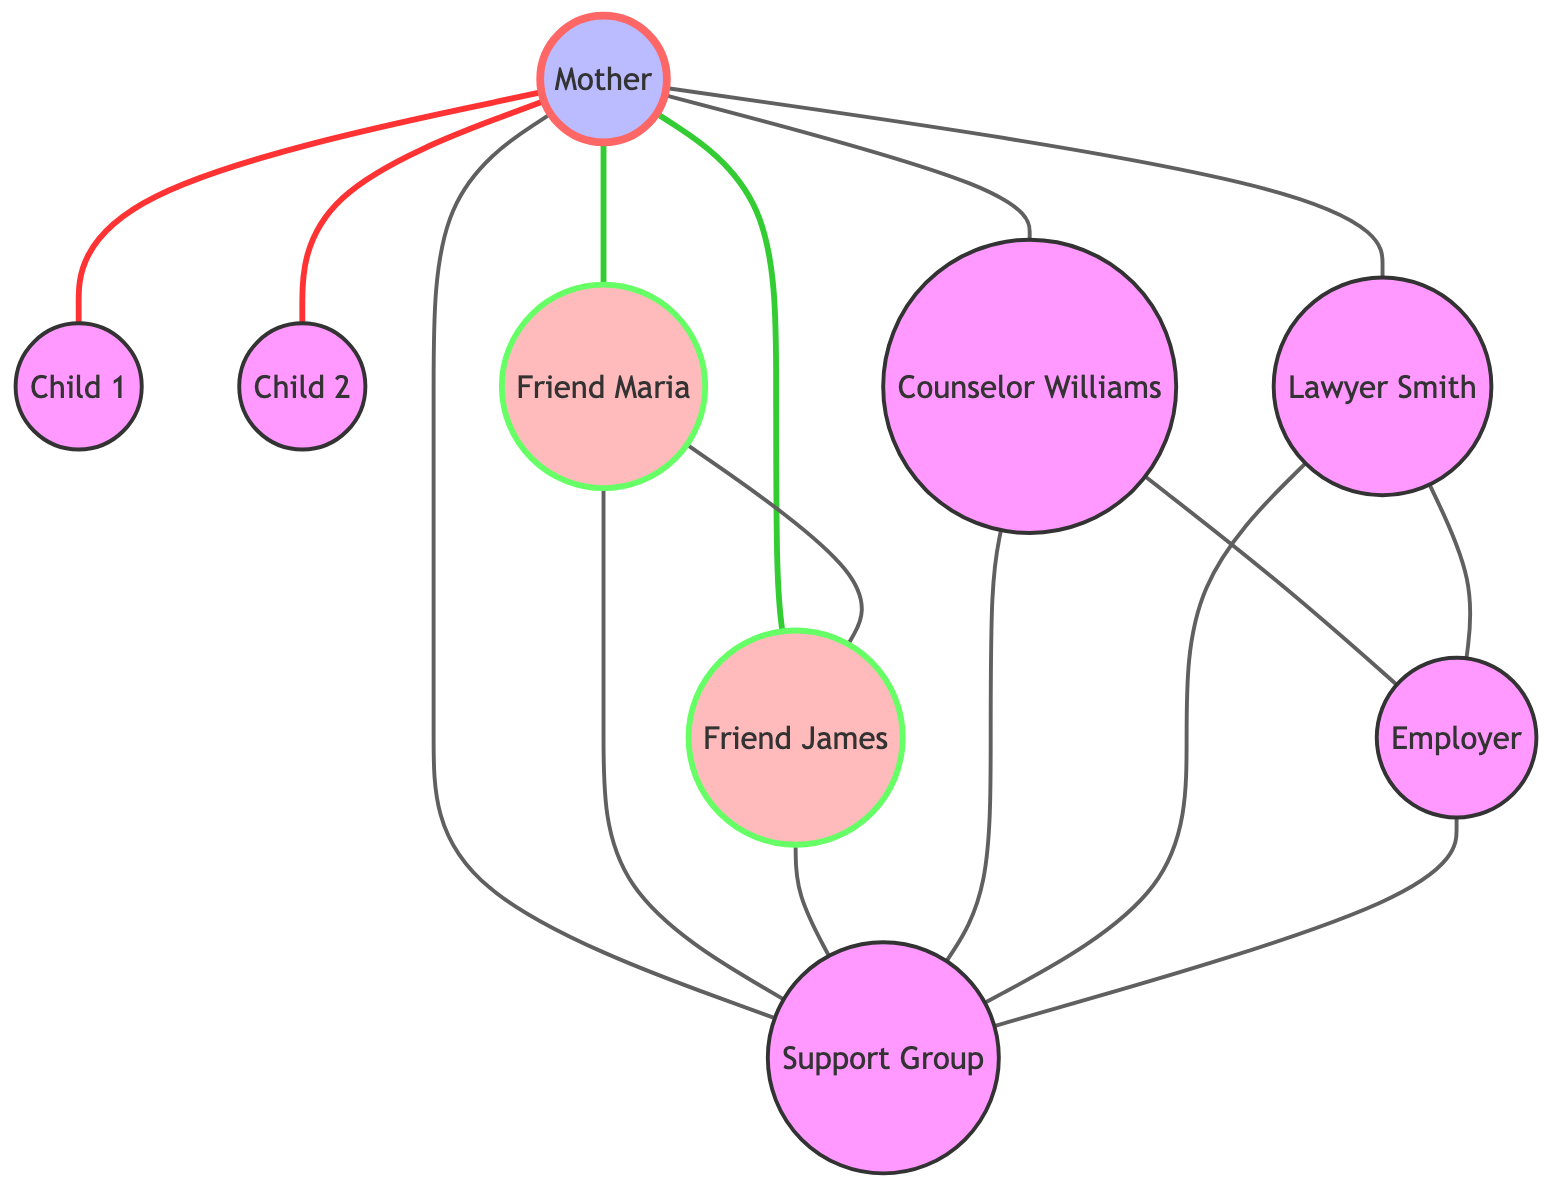What is the total number of nodes in the graph? The graph contains the following nodes: Mother, Child 1, Child 2, Friend Maria, Friend James, Counselor Williams, Lawyer Smith, Support Group, and Employer. Counting these gives a total of 9 nodes.
Answer: 9 Who is directly connected to the Mother? From the diagram, the Mother has direct connections to Child 1, Child 2, Friend Maria, Friend James, Counselor Williams, Lawyer Smith, and Support Group. The relationships are represented by edges that lead to these nodes.
Answer: Child 1, Child 2, Friend Maria, Friend James, Counselor Williams, Lawyer Smith, Support Group How many connections does Friend Maria have? Friend Maria is connected to three nodes: the Mother, Friend James, and the Support Group. Counting these gives a total of three connections.
Answer: 3 Which node is connected to both the Counselor Williams and the Employer? Looking at the edges, the Counselor Williams has a direct connection to the Employer. This means both nodes are adjacent in the undirected graph and linked through an edge.
Answer: Employer Are Friend Maria and Friend James connected? The graph shows a direct connection between Friend Maria and Friend James, which is represented by an edge linking these two nodes.
Answer: Yes What is the role of Lawyer Smith in the emotional support system? Lawyer Smith is connected to the Mother, Support Group, and Employer, indicating their involvement in providing legal assistance as part of the overall emotional support.
Answer: Legal assistance How many edges are present in the graph? The edges are the connections between the nodes in the graph. Counting all edges gives a total of 14 connections.
Answer: 14 Which two nodes have a direct relationship with the Support Group? The Support Group connects directly to Friend Maria, Friend James, Counselor Williams, Lawyer Smith, and Employer. Two examples of nodes with direct relationships are Counselor Williams and Employer.
Answer: Counselor Williams, Employer What type of connections exist between the nodes in the graph? The connections between the nodes in the undirected graph are bidirectional, which means that the relationship can be traversed in both directions, indicating mutual support.
Answer: Bidirectional 